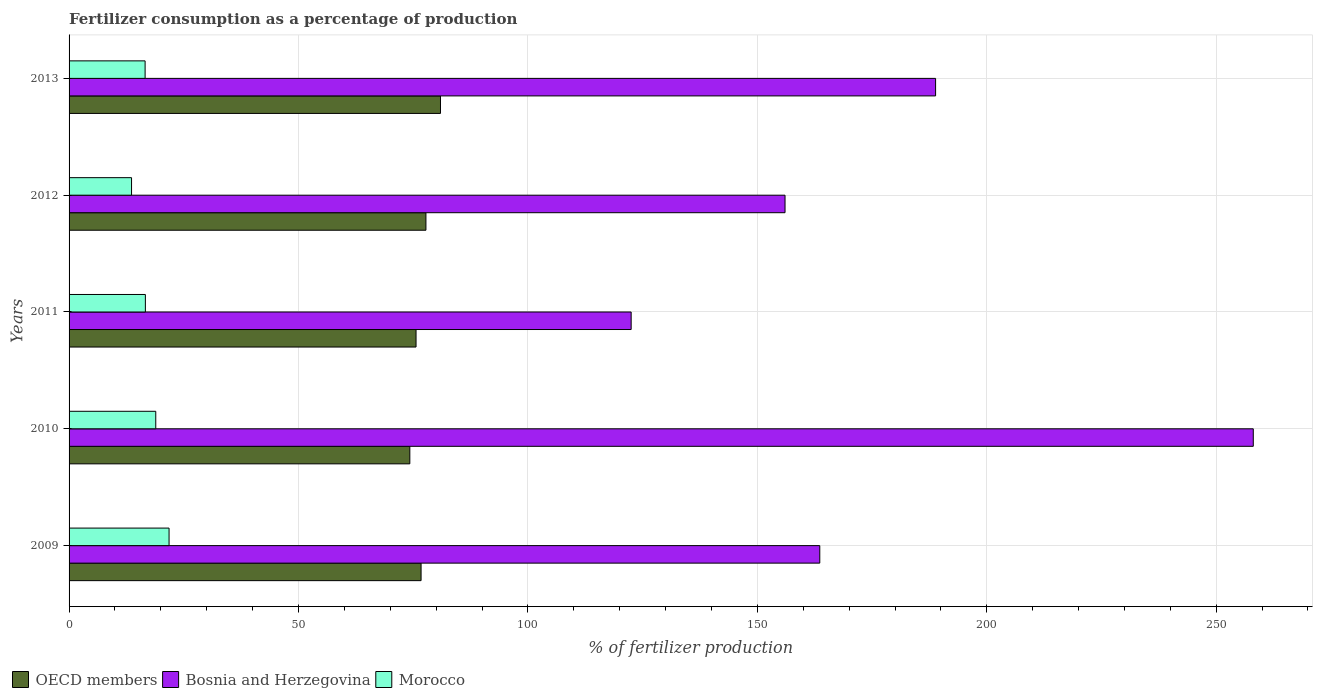How many groups of bars are there?
Offer a very short reply. 5. How many bars are there on the 1st tick from the bottom?
Offer a very short reply. 3. What is the label of the 2nd group of bars from the top?
Ensure brevity in your answer.  2012. What is the percentage of fertilizers consumed in OECD members in 2009?
Provide a succinct answer. 76.72. Across all years, what is the maximum percentage of fertilizers consumed in Bosnia and Herzegovina?
Your answer should be compact. 258.08. Across all years, what is the minimum percentage of fertilizers consumed in Bosnia and Herzegovina?
Provide a short and direct response. 122.5. In which year was the percentage of fertilizers consumed in Morocco maximum?
Ensure brevity in your answer.  2009. In which year was the percentage of fertilizers consumed in Morocco minimum?
Your answer should be compact. 2012. What is the total percentage of fertilizers consumed in OECD members in the graph?
Keep it short and to the point. 385.32. What is the difference between the percentage of fertilizers consumed in OECD members in 2009 and that in 2010?
Give a very brief answer. 2.45. What is the difference between the percentage of fertilizers consumed in Morocco in 2009 and the percentage of fertilizers consumed in OECD members in 2013?
Make the answer very short. -59.15. What is the average percentage of fertilizers consumed in Morocco per year?
Ensure brevity in your answer.  17.5. In the year 2011, what is the difference between the percentage of fertilizers consumed in OECD members and percentage of fertilizers consumed in Morocco?
Provide a succinct answer. 58.99. In how many years, is the percentage of fertilizers consumed in Bosnia and Herzegovina greater than 120 %?
Make the answer very short. 5. What is the ratio of the percentage of fertilizers consumed in OECD members in 2011 to that in 2013?
Provide a succinct answer. 0.93. Is the percentage of fertilizers consumed in Bosnia and Herzegovina in 2009 less than that in 2012?
Keep it short and to the point. No. What is the difference between the highest and the second highest percentage of fertilizers consumed in Morocco?
Your response must be concise. 2.9. What is the difference between the highest and the lowest percentage of fertilizers consumed in OECD members?
Give a very brief answer. 6.68. What does the 1st bar from the top in 2012 represents?
Your answer should be compact. Morocco. What does the 2nd bar from the bottom in 2009 represents?
Make the answer very short. Bosnia and Herzegovina. Is it the case that in every year, the sum of the percentage of fertilizers consumed in Morocco and percentage of fertilizers consumed in OECD members is greater than the percentage of fertilizers consumed in Bosnia and Herzegovina?
Your answer should be compact. No. Are the values on the major ticks of X-axis written in scientific E-notation?
Offer a very short reply. No. Where does the legend appear in the graph?
Provide a short and direct response. Bottom left. How many legend labels are there?
Provide a short and direct response. 3. What is the title of the graph?
Offer a terse response. Fertilizer consumption as a percentage of production. What is the label or title of the X-axis?
Provide a succinct answer. % of fertilizer production. What is the label or title of the Y-axis?
Provide a succinct answer. Years. What is the % of fertilizer production of OECD members in 2009?
Make the answer very short. 76.72. What is the % of fertilizer production in Bosnia and Herzegovina in 2009?
Give a very brief answer. 163.61. What is the % of fertilizer production in Morocco in 2009?
Make the answer very short. 21.79. What is the % of fertilizer production of OECD members in 2010?
Your answer should be compact. 74.26. What is the % of fertilizer production of Bosnia and Herzegovina in 2010?
Your answer should be compact. 258.08. What is the % of fertilizer production in Morocco in 2010?
Give a very brief answer. 18.9. What is the % of fertilizer production of OECD members in 2011?
Offer a very short reply. 75.62. What is the % of fertilizer production of Bosnia and Herzegovina in 2011?
Your answer should be very brief. 122.5. What is the % of fertilizer production in Morocco in 2011?
Make the answer very short. 16.63. What is the % of fertilizer production of OECD members in 2012?
Provide a short and direct response. 77.78. What is the % of fertilizer production in Bosnia and Herzegovina in 2012?
Keep it short and to the point. 156.04. What is the % of fertilizer production in Morocco in 2012?
Ensure brevity in your answer.  13.62. What is the % of fertilizer production in OECD members in 2013?
Provide a short and direct response. 80.95. What is the % of fertilizer production in Bosnia and Herzegovina in 2013?
Keep it short and to the point. 188.85. What is the % of fertilizer production of Morocco in 2013?
Provide a short and direct response. 16.57. Across all years, what is the maximum % of fertilizer production of OECD members?
Make the answer very short. 80.95. Across all years, what is the maximum % of fertilizer production of Bosnia and Herzegovina?
Make the answer very short. 258.08. Across all years, what is the maximum % of fertilizer production in Morocco?
Ensure brevity in your answer.  21.79. Across all years, what is the minimum % of fertilizer production of OECD members?
Offer a very short reply. 74.26. Across all years, what is the minimum % of fertilizer production of Bosnia and Herzegovina?
Keep it short and to the point. 122.5. Across all years, what is the minimum % of fertilizer production of Morocco?
Keep it short and to the point. 13.62. What is the total % of fertilizer production of OECD members in the graph?
Ensure brevity in your answer.  385.32. What is the total % of fertilizer production of Bosnia and Herzegovina in the graph?
Offer a terse response. 889.07. What is the total % of fertilizer production of Morocco in the graph?
Offer a terse response. 87.51. What is the difference between the % of fertilizer production of OECD members in 2009 and that in 2010?
Provide a succinct answer. 2.45. What is the difference between the % of fertilizer production in Bosnia and Herzegovina in 2009 and that in 2010?
Provide a short and direct response. -94.48. What is the difference between the % of fertilizer production in Morocco in 2009 and that in 2010?
Your response must be concise. 2.9. What is the difference between the % of fertilizer production in OECD members in 2009 and that in 2011?
Provide a short and direct response. 1.1. What is the difference between the % of fertilizer production in Bosnia and Herzegovina in 2009 and that in 2011?
Give a very brief answer. 41.11. What is the difference between the % of fertilizer production in Morocco in 2009 and that in 2011?
Your answer should be very brief. 5.16. What is the difference between the % of fertilizer production in OECD members in 2009 and that in 2012?
Your answer should be very brief. -1.06. What is the difference between the % of fertilizer production in Bosnia and Herzegovina in 2009 and that in 2012?
Provide a succinct answer. 7.57. What is the difference between the % of fertilizer production in Morocco in 2009 and that in 2012?
Offer a terse response. 8.18. What is the difference between the % of fertilizer production in OECD members in 2009 and that in 2013?
Offer a terse response. -4.23. What is the difference between the % of fertilizer production in Bosnia and Herzegovina in 2009 and that in 2013?
Provide a short and direct response. -25.24. What is the difference between the % of fertilizer production of Morocco in 2009 and that in 2013?
Ensure brevity in your answer.  5.22. What is the difference between the % of fertilizer production of OECD members in 2010 and that in 2011?
Make the answer very short. -1.35. What is the difference between the % of fertilizer production of Bosnia and Herzegovina in 2010 and that in 2011?
Keep it short and to the point. 135.58. What is the difference between the % of fertilizer production in Morocco in 2010 and that in 2011?
Your answer should be very brief. 2.26. What is the difference between the % of fertilizer production of OECD members in 2010 and that in 2012?
Provide a short and direct response. -3.51. What is the difference between the % of fertilizer production in Bosnia and Herzegovina in 2010 and that in 2012?
Provide a short and direct response. 102.05. What is the difference between the % of fertilizer production of Morocco in 2010 and that in 2012?
Your answer should be very brief. 5.28. What is the difference between the % of fertilizer production in OECD members in 2010 and that in 2013?
Make the answer very short. -6.68. What is the difference between the % of fertilizer production in Bosnia and Herzegovina in 2010 and that in 2013?
Keep it short and to the point. 69.24. What is the difference between the % of fertilizer production of Morocco in 2010 and that in 2013?
Your answer should be compact. 2.32. What is the difference between the % of fertilizer production of OECD members in 2011 and that in 2012?
Keep it short and to the point. -2.16. What is the difference between the % of fertilizer production in Bosnia and Herzegovina in 2011 and that in 2012?
Keep it short and to the point. -33.54. What is the difference between the % of fertilizer production in Morocco in 2011 and that in 2012?
Give a very brief answer. 3.01. What is the difference between the % of fertilizer production in OECD members in 2011 and that in 2013?
Your answer should be very brief. -5.33. What is the difference between the % of fertilizer production of Bosnia and Herzegovina in 2011 and that in 2013?
Keep it short and to the point. -66.35. What is the difference between the % of fertilizer production in Morocco in 2011 and that in 2013?
Your answer should be very brief. 0.06. What is the difference between the % of fertilizer production of OECD members in 2012 and that in 2013?
Offer a terse response. -3.17. What is the difference between the % of fertilizer production in Bosnia and Herzegovina in 2012 and that in 2013?
Give a very brief answer. -32.81. What is the difference between the % of fertilizer production of Morocco in 2012 and that in 2013?
Your answer should be compact. -2.96. What is the difference between the % of fertilizer production of OECD members in 2009 and the % of fertilizer production of Bosnia and Herzegovina in 2010?
Keep it short and to the point. -181.37. What is the difference between the % of fertilizer production of OECD members in 2009 and the % of fertilizer production of Morocco in 2010?
Make the answer very short. 57.82. What is the difference between the % of fertilizer production in Bosnia and Herzegovina in 2009 and the % of fertilizer production in Morocco in 2010?
Ensure brevity in your answer.  144.71. What is the difference between the % of fertilizer production of OECD members in 2009 and the % of fertilizer production of Bosnia and Herzegovina in 2011?
Provide a succinct answer. -45.78. What is the difference between the % of fertilizer production of OECD members in 2009 and the % of fertilizer production of Morocco in 2011?
Offer a very short reply. 60.08. What is the difference between the % of fertilizer production of Bosnia and Herzegovina in 2009 and the % of fertilizer production of Morocco in 2011?
Keep it short and to the point. 146.98. What is the difference between the % of fertilizer production of OECD members in 2009 and the % of fertilizer production of Bosnia and Herzegovina in 2012?
Offer a terse response. -79.32. What is the difference between the % of fertilizer production of OECD members in 2009 and the % of fertilizer production of Morocco in 2012?
Your response must be concise. 63.1. What is the difference between the % of fertilizer production of Bosnia and Herzegovina in 2009 and the % of fertilizer production of Morocco in 2012?
Your response must be concise. 149.99. What is the difference between the % of fertilizer production of OECD members in 2009 and the % of fertilizer production of Bosnia and Herzegovina in 2013?
Your answer should be very brief. -112.13. What is the difference between the % of fertilizer production in OECD members in 2009 and the % of fertilizer production in Morocco in 2013?
Your answer should be very brief. 60.14. What is the difference between the % of fertilizer production in Bosnia and Herzegovina in 2009 and the % of fertilizer production in Morocco in 2013?
Your answer should be compact. 147.03. What is the difference between the % of fertilizer production in OECD members in 2010 and the % of fertilizer production in Bosnia and Herzegovina in 2011?
Your response must be concise. -48.24. What is the difference between the % of fertilizer production in OECD members in 2010 and the % of fertilizer production in Morocco in 2011?
Offer a terse response. 57.63. What is the difference between the % of fertilizer production of Bosnia and Herzegovina in 2010 and the % of fertilizer production of Morocco in 2011?
Your answer should be very brief. 241.45. What is the difference between the % of fertilizer production in OECD members in 2010 and the % of fertilizer production in Bosnia and Herzegovina in 2012?
Provide a short and direct response. -81.77. What is the difference between the % of fertilizer production in OECD members in 2010 and the % of fertilizer production in Morocco in 2012?
Your answer should be compact. 60.65. What is the difference between the % of fertilizer production of Bosnia and Herzegovina in 2010 and the % of fertilizer production of Morocco in 2012?
Provide a succinct answer. 244.47. What is the difference between the % of fertilizer production in OECD members in 2010 and the % of fertilizer production in Bosnia and Herzegovina in 2013?
Make the answer very short. -114.58. What is the difference between the % of fertilizer production of OECD members in 2010 and the % of fertilizer production of Morocco in 2013?
Keep it short and to the point. 57.69. What is the difference between the % of fertilizer production of Bosnia and Herzegovina in 2010 and the % of fertilizer production of Morocco in 2013?
Your answer should be very brief. 241.51. What is the difference between the % of fertilizer production of OECD members in 2011 and the % of fertilizer production of Bosnia and Herzegovina in 2012?
Provide a succinct answer. -80.42. What is the difference between the % of fertilizer production in OECD members in 2011 and the % of fertilizer production in Morocco in 2012?
Give a very brief answer. 62. What is the difference between the % of fertilizer production in Bosnia and Herzegovina in 2011 and the % of fertilizer production in Morocco in 2012?
Your response must be concise. 108.88. What is the difference between the % of fertilizer production of OECD members in 2011 and the % of fertilizer production of Bosnia and Herzegovina in 2013?
Ensure brevity in your answer.  -113.23. What is the difference between the % of fertilizer production of OECD members in 2011 and the % of fertilizer production of Morocco in 2013?
Ensure brevity in your answer.  59.05. What is the difference between the % of fertilizer production in Bosnia and Herzegovina in 2011 and the % of fertilizer production in Morocco in 2013?
Ensure brevity in your answer.  105.93. What is the difference between the % of fertilizer production of OECD members in 2012 and the % of fertilizer production of Bosnia and Herzegovina in 2013?
Your response must be concise. -111.07. What is the difference between the % of fertilizer production in OECD members in 2012 and the % of fertilizer production in Morocco in 2013?
Offer a terse response. 61.2. What is the difference between the % of fertilizer production in Bosnia and Herzegovina in 2012 and the % of fertilizer production in Morocco in 2013?
Give a very brief answer. 139.46. What is the average % of fertilizer production of OECD members per year?
Ensure brevity in your answer.  77.06. What is the average % of fertilizer production in Bosnia and Herzegovina per year?
Offer a very short reply. 177.81. What is the average % of fertilizer production of Morocco per year?
Make the answer very short. 17.5. In the year 2009, what is the difference between the % of fertilizer production of OECD members and % of fertilizer production of Bosnia and Herzegovina?
Provide a short and direct response. -86.89. In the year 2009, what is the difference between the % of fertilizer production in OECD members and % of fertilizer production in Morocco?
Provide a short and direct response. 54.92. In the year 2009, what is the difference between the % of fertilizer production of Bosnia and Herzegovina and % of fertilizer production of Morocco?
Keep it short and to the point. 141.81. In the year 2010, what is the difference between the % of fertilizer production of OECD members and % of fertilizer production of Bosnia and Herzegovina?
Provide a short and direct response. -183.82. In the year 2010, what is the difference between the % of fertilizer production in OECD members and % of fertilizer production in Morocco?
Offer a terse response. 55.37. In the year 2010, what is the difference between the % of fertilizer production in Bosnia and Herzegovina and % of fertilizer production in Morocco?
Give a very brief answer. 239.19. In the year 2011, what is the difference between the % of fertilizer production of OECD members and % of fertilizer production of Bosnia and Herzegovina?
Provide a succinct answer. -46.88. In the year 2011, what is the difference between the % of fertilizer production in OECD members and % of fertilizer production in Morocco?
Provide a short and direct response. 58.99. In the year 2011, what is the difference between the % of fertilizer production in Bosnia and Herzegovina and % of fertilizer production in Morocco?
Offer a terse response. 105.87. In the year 2012, what is the difference between the % of fertilizer production in OECD members and % of fertilizer production in Bosnia and Herzegovina?
Your answer should be compact. -78.26. In the year 2012, what is the difference between the % of fertilizer production in OECD members and % of fertilizer production in Morocco?
Offer a very short reply. 64.16. In the year 2012, what is the difference between the % of fertilizer production of Bosnia and Herzegovina and % of fertilizer production of Morocco?
Your answer should be very brief. 142.42. In the year 2013, what is the difference between the % of fertilizer production in OECD members and % of fertilizer production in Bosnia and Herzegovina?
Offer a terse response. -107.9. In the year 2013, what is the difference between the % of fertilizer production in OECD members and % of fertilizer production in Morocco?
Make the answer very short. 64.37. In the year 2013, what is the difference between the % of fertilizer production of Bosnia and Herzegovina and % of fertilizer production of Morocco?
Ensure brevity in your answer.  172.28. What is the ratio of the % of fertilizer production in OECD members in 2009 to that in 2010?
Provide a succinct answer. 1.03. What is the ratio of the % of fertilizer production in Bosnia and Herzegovina in 2009 to that in 2010?
Give a very brief answer. 0.63. What is the ratio of the % of fertilizer production in Morocco in 2009 to that in 2010?
Your response must be concise. 1.15. What is the ratio of the % of fertilizer production of OECD members in 2009 to that in 2011?
Keep it short and to the point. 1.01. What is the ratio of the % of fertilizer production of Bosnia and Herzegovina in 2009 to that in 2011?
Make the answer very short. 1.34. What is the ratio of the % of fertilizer production in Morocco in 2009 to that in 2011?
Ensure brevity in your answer.  1.31. What is the ratio of the % of fertilizer production of OECD members in 2009 to that in 2012?
Make the answer very short. 0.99. What is the ratio of the % of fertilizer production in Bosnia and Herzegovina in 2009 to that in 2012?
Give a very brief answer. 1.05. What is the ratio of the % of fertilizer production in Morocco in 2009 to that in 2012?
Offer a very short reply. 1.6. What is the ratio of the % of fertilizer production of OECD members in 2009 to that in 2013?
Keep it short and to the point. 0.95. What is the ratio of the % of fertilizer production of Bosnia and Herzegovina in 2009 to that in 2013?
Give a very brief answer. 0.87. What is the ratio of the % of fertilizer production in Morocco in 2009 to that in 2013?
Your answer should be compact. 1.31. What is the ratio of the % of fertilizer production of OECD members in 2010 to that in 2011?
Your answer should be very brief. 0.98. What is the ratio of the % of fertilizer production in Bosnia and Herzegovina in 2010 to that in 2011?
Your answer should be compact. 2.11. What is the ratio of the % of fertilizer production of Morocco in 2010 to that in 2011?
Your response must be concise. 1.14. What is the ratio of the % of fertilizer production of OECD members in 2010 to that in 2012?
Your response must be concise. 0.95. What is the ratio of the % of fertilizer production in Bosnia and Herzegovina in 2010 to that in 2012?
Your answer should be very brief. 1.65. What is the ratio of the % of fertilizer production in Morocco in 2010 to that in 2012?
Provide a succinct answer. 1.39. What is the ratio of the % of fertilizer production in OECD members in 2010 to that in 2013?
Your answer should be compact. 0.92. What is the ratio of the % of fertilizer production in Bosnia and Herzegovina in 2010 to that in 2013?
Ensure brevity in your answer.  1.37. What is the ratio of the % of fertilizer production of Morocco in 2010 to that in 2013?
Ensure brevity in your answer.  1.14. What is the ratio of the % of fertilizer production of OECD members in 2011 to that in 2012?
Ensure brevity in your answer.  0.97. What is the ratio of the % of fertilizer production of Bosnia and Herzegovina in 2011 to that in 2012?
Ensure brevity in your answer.  0.79. What is the ratio of the % of fertilizer production of Morocco in 2011 to that in 2012?
Provide a short and direct response. 1.22. What is the ratio of the % of fertilizer production of OECD members in 2011 to that in 2013?
Ensure brevity in your answer.  0.93. What is the ratio of the % of fertilizer production of Bosnia and Herzegovina in 2011 to that in 2013?
Provide a short and direct response. 0.65. What is the ratio of the % of fertilizer production of OECD members in 2012 to that in 2013?
Ensure brevity in your answer.  0.96. What is the ratio of the % of fertilizer production of Bosnia and Herzegovina in 2012 to that in 2013?
Offer a very short reply. 0.83. What is the ratio of the % of fertilizer production in Morocco in 2012 to that in 2013?
Provide a short and direct response. 0.82. What is the difference between the highest and the second highest % of fertilizer production of OECD members?
Provide a succinct answer. 3.17. What is the difference between the highest and the second highest % of fertilizer production in Bosnia and Herzegovina?
Provide a short and direct response. 69.24. What is the difference between the highest and the second highest % of fertilizer production in Morocco?
Offer a very short reply. 2.9. What is the difference between the highest and the lowest % of fertilizer production of OECD members?
Give a very brief answer. 6.68. What is the difference between the highest and the lowest % of fertilizer production of Bosnia and Herzegovina?
Your response must be concise. 135.58. What is the difference between the highest and the lowest % of fertilizer production of Morocco?
Offer a terse response. 8.18. 